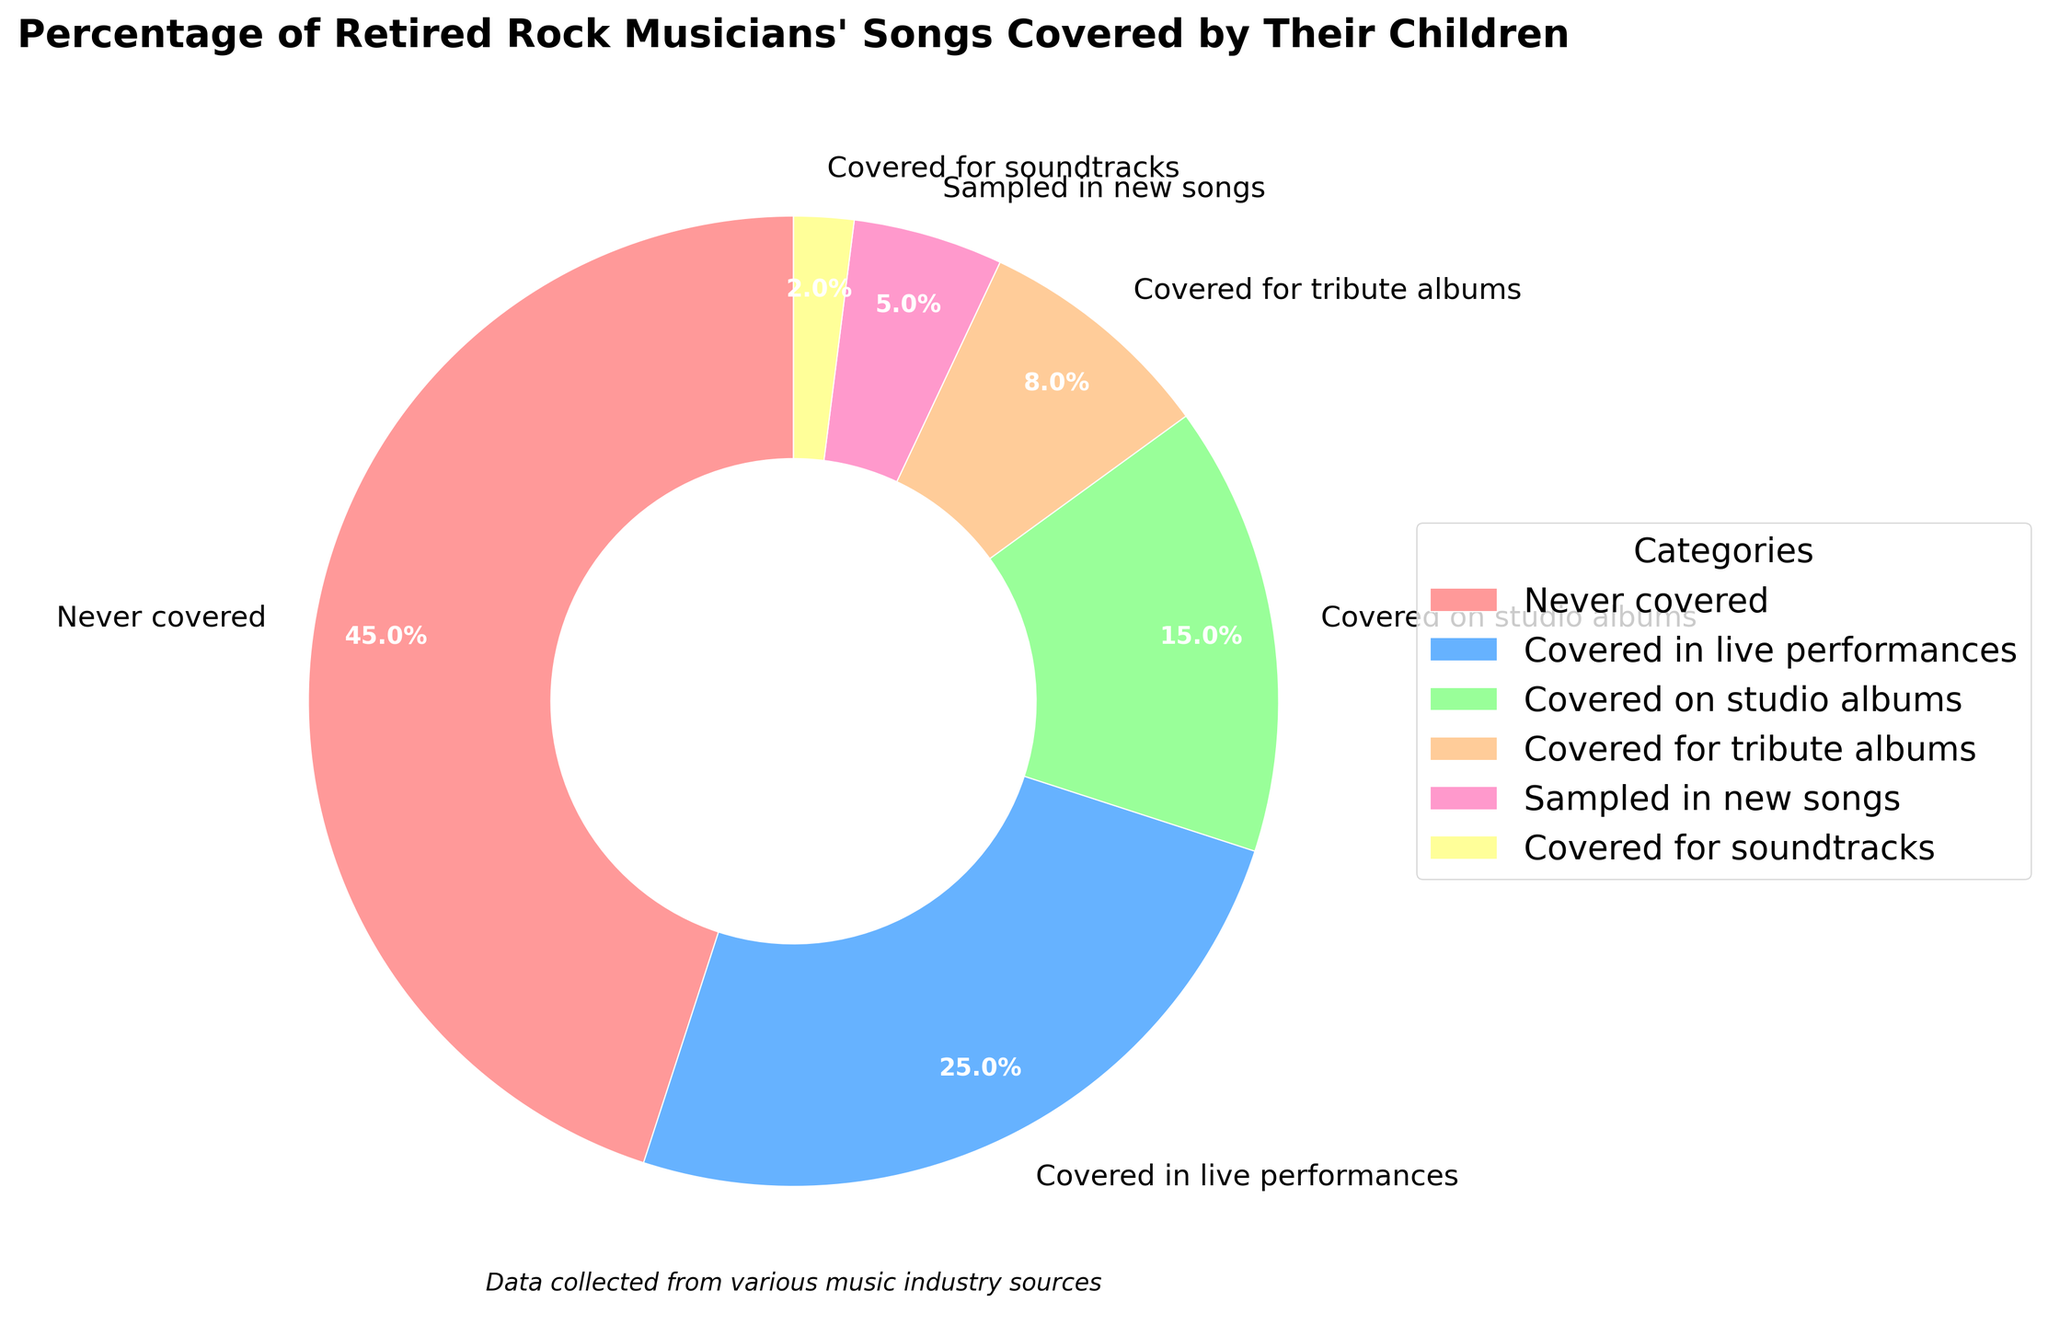What is the category with the highest percentage of songs covered by children? The chart shows six categories for how retired rock musicians' songs are covered by their children. The category with the highest percentage is "Never covered," which has a 45% share.
Answer: Never covered How much higher is the percentage of songs covered in live performances compared to those covered on studio albums? The percentage of songs covered in live performances is 25%, and the percentage for songs covered on studio albums is 15%. Subtracting these gives 25% - 15% = 10%.
Answer: 10% Which categories combine to make up more than 50% of the coverage? Adding the percentages of each category until the sum exceeds 50%: "Never covered" (45%) + "Covered in live performances" (25%) = 70%, which is more than 50%. So these two categories combined make up more than 50%.
Answer: Never covered and Covered in live performances What is the sum of the percentages of songs covered for tribute albums, sampled in new songs, and covered for soundtracks? Add up the percentages of the three mentioned categories: 8% (tribute albums) + 5% (sampled in new songs) + 2% (soundtracks) = 15%.
Answer: 15% Compare the coverage percentage of songs on studio albums to those covered for tribute albums. Which is higher and by how much? The percentage for studio albums is 15%, and for tribute albums, it is 8%. Subtracting these gives 15% - 8% = 7%, so studio album coverage is higher by 7%.
Answer: Studio album coverage is higher by 7% What percentage of retired rock musicians' songs are covered, according to the pie chart? To determine the total percentage of covered songs, add the percentages of all covered categories: 25% (live performances) + 15% (studio albums) + 8% (tribute albums) + 5% (sampled in new songs) + 2% (soundtracks) = 55%.
Answer: 55% How does the percentage of songs sampled in new songs compare to the percentage of songs covered for soundtracks? The pie chart shows that 5% of songs are sampled in new songs, while only 2% are covered for soundtracks. 5% is greater than 2%, making the former higher by 3%.
Answer: Songs sampled in new songs is higher by 3% Which category is represented by the smallest wedge in the pie chart? The smallest wedge in the chart represents the category with the lowest percentage. According to the data, this is "Covered for soundtracks," which has a 2% share.
Answer: Covered for soundtracks What percentage of songs are not covered by the children of retired rock musicians? The category "Never covered" explicitly indicates songs not covered, with a percentage of 45%.
Answer: 45% In total, how many categories are represented in the pie chart? By counting the wedges in the pie chart or referring to the listed data categories, we can see there are six categories.
Answer: 6 